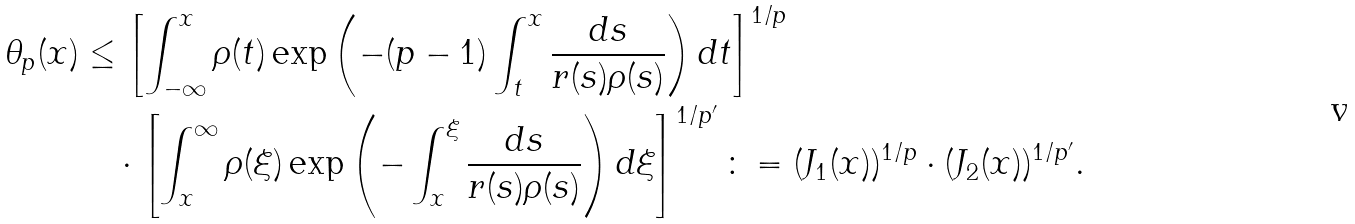Convert formula to latex. <formula><loc_0><loc_0><loc_500><loc_500>\theta _ { p } ( x ) & \leq \left [ \int _ { - \infty } ^ { x } \rho ( t ) \exp \left ( - ( p - 1 ) \int _ { t } ^ { x } \frac { d s } { r ( s ) \rho ( s ) } \right ) d t \right ] ^ { 1 / p } \\ & \quad \cdot \left [ \int _ { x } ^ { \infty } \rho ( \xi ) \exp \left ( - \int _ { x } ^ { \xi } \frac { d s } { r ( s ) \rho ( s ) } \right ) d \xi \right ] ^ { 1 / p ^ { \prime } } \colon = ( J _ { 1 } ( x ) ) ^ { 1 / p } \cdot ( J _ { 2 } ( x ) ) ^ { 1 / p ^ { \prime } } .</formula> 